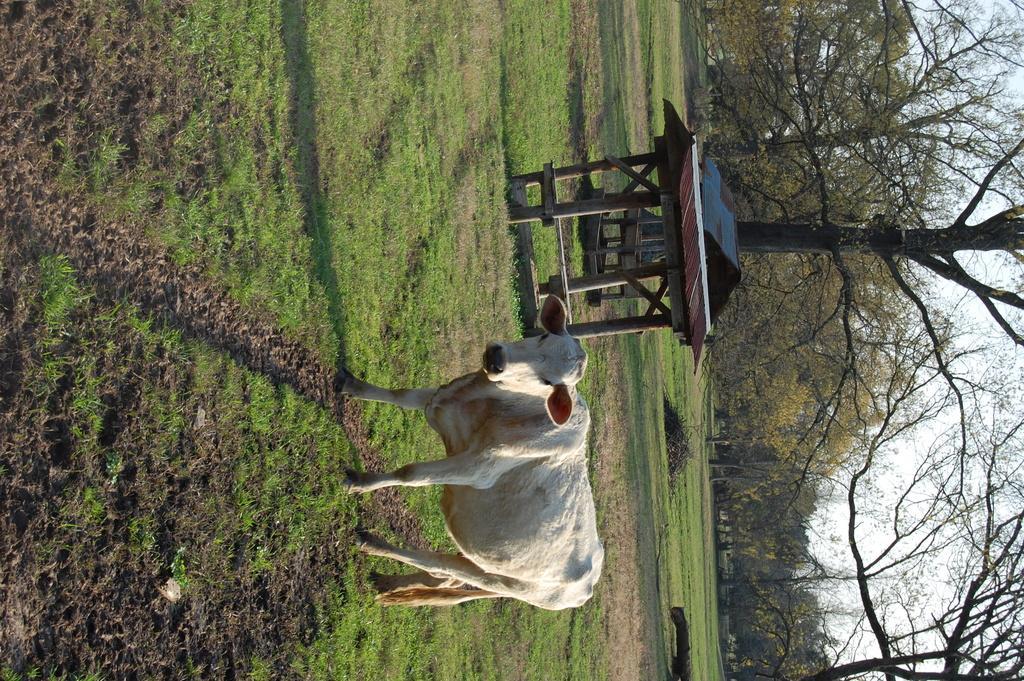Can you describe this image briefly? This image is taken outdoors. On the left side of the image there is a ground with grass on it. On the right side of the image there are many trees and there is a sky. In the middle of the image there is a cow and two wooden cabins on the ground. 